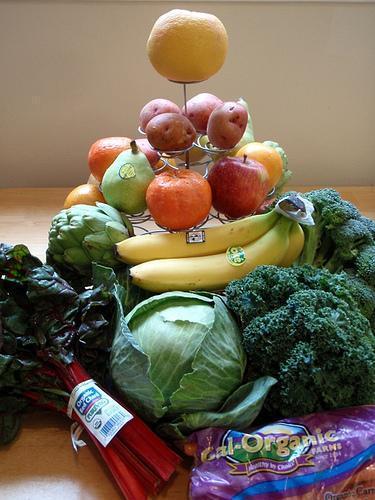How many potatoes are there?
Give a very brief answer. 4. How many apples are there?
Give a very brief answer. 2. How many oranges are there?
Give a very brief answer. 2. How many women are hugging the fire hydrant?
Give a very brief answer. 0. 